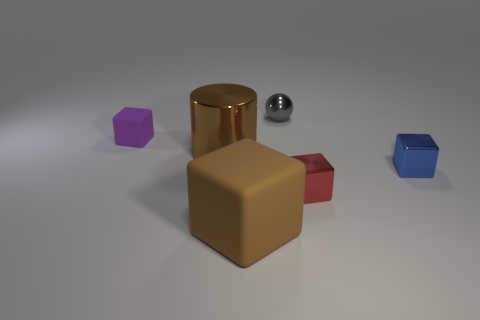Add 3 big cylinders. How many objects exist? 9 Subtract all gray blocks. Subtract all cyan balls. How many blocks are left? 4 Subtract all cubes. How many objects are left? 2 Subtract all metal cylinders. Subtract all cyan things. How many objects are left? 5 Add 6 red things. How many red things are left? 7 Add 2 small gray things. How many small gray things exist? 3 Subtract 0 yellow cylinders. How many objects are left? 6 